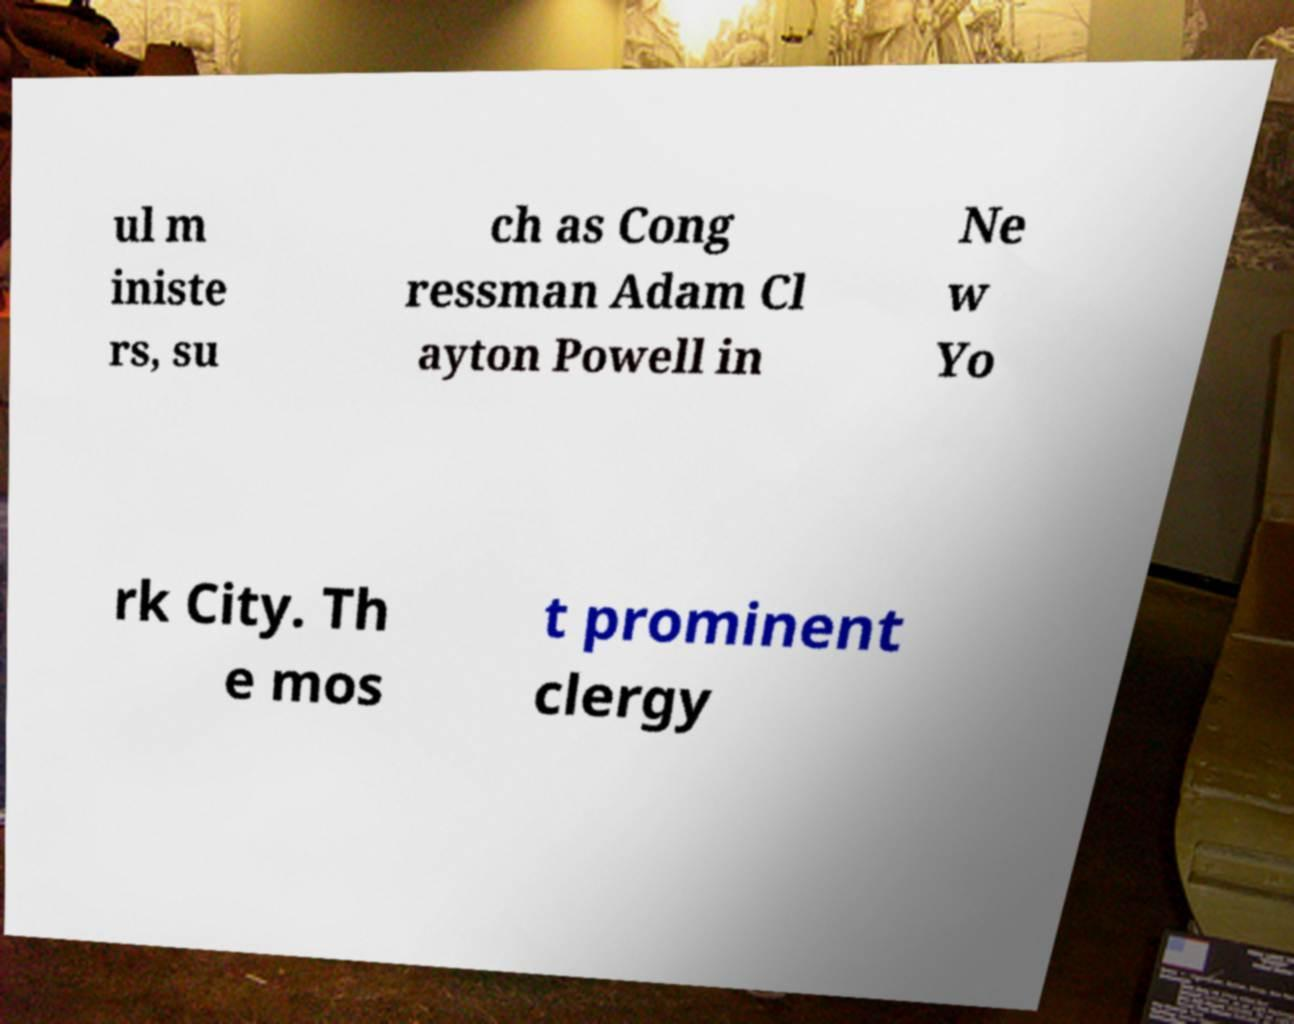Could you extract and type out the text from this image? ul m iniste rs, su ch as Cong ressman Adam Cl ayton Powell in Ne w Yo rk City. Th e mos t prominent clergy 